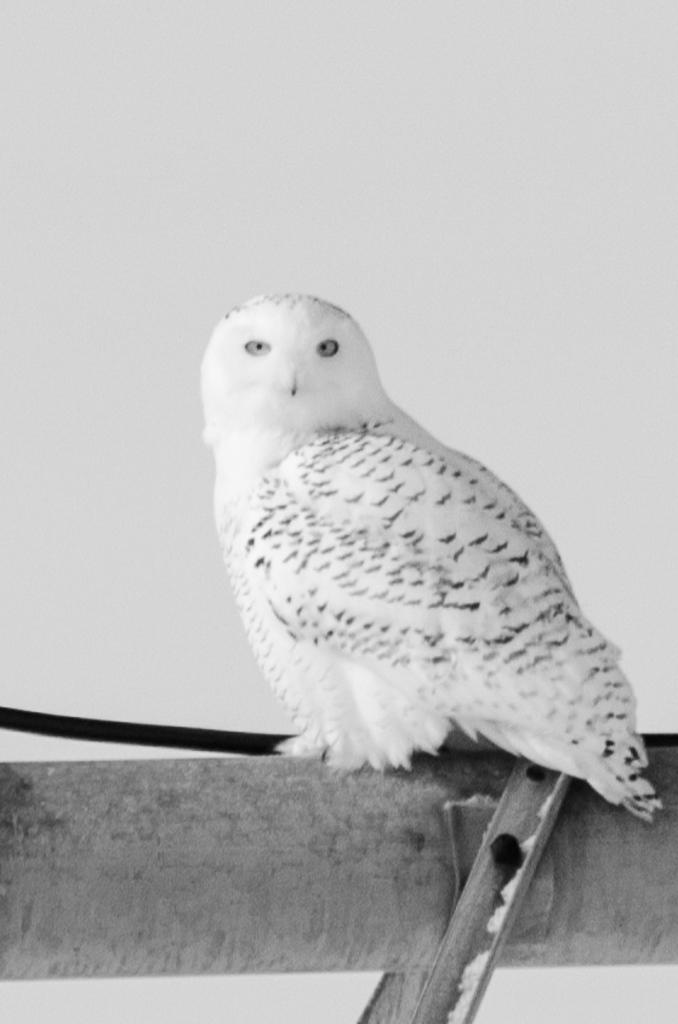What type of animal is in the image? There is an owl in the image. What colors are present on the owl? The owl is black and white in color. What other black object can be seen in the image? There is a black colored object in the image. What color is the background of the image? The background of the image is white. How many pans can be seen hanging from the icicle in the image? There are no pans or icicles present in the image. 